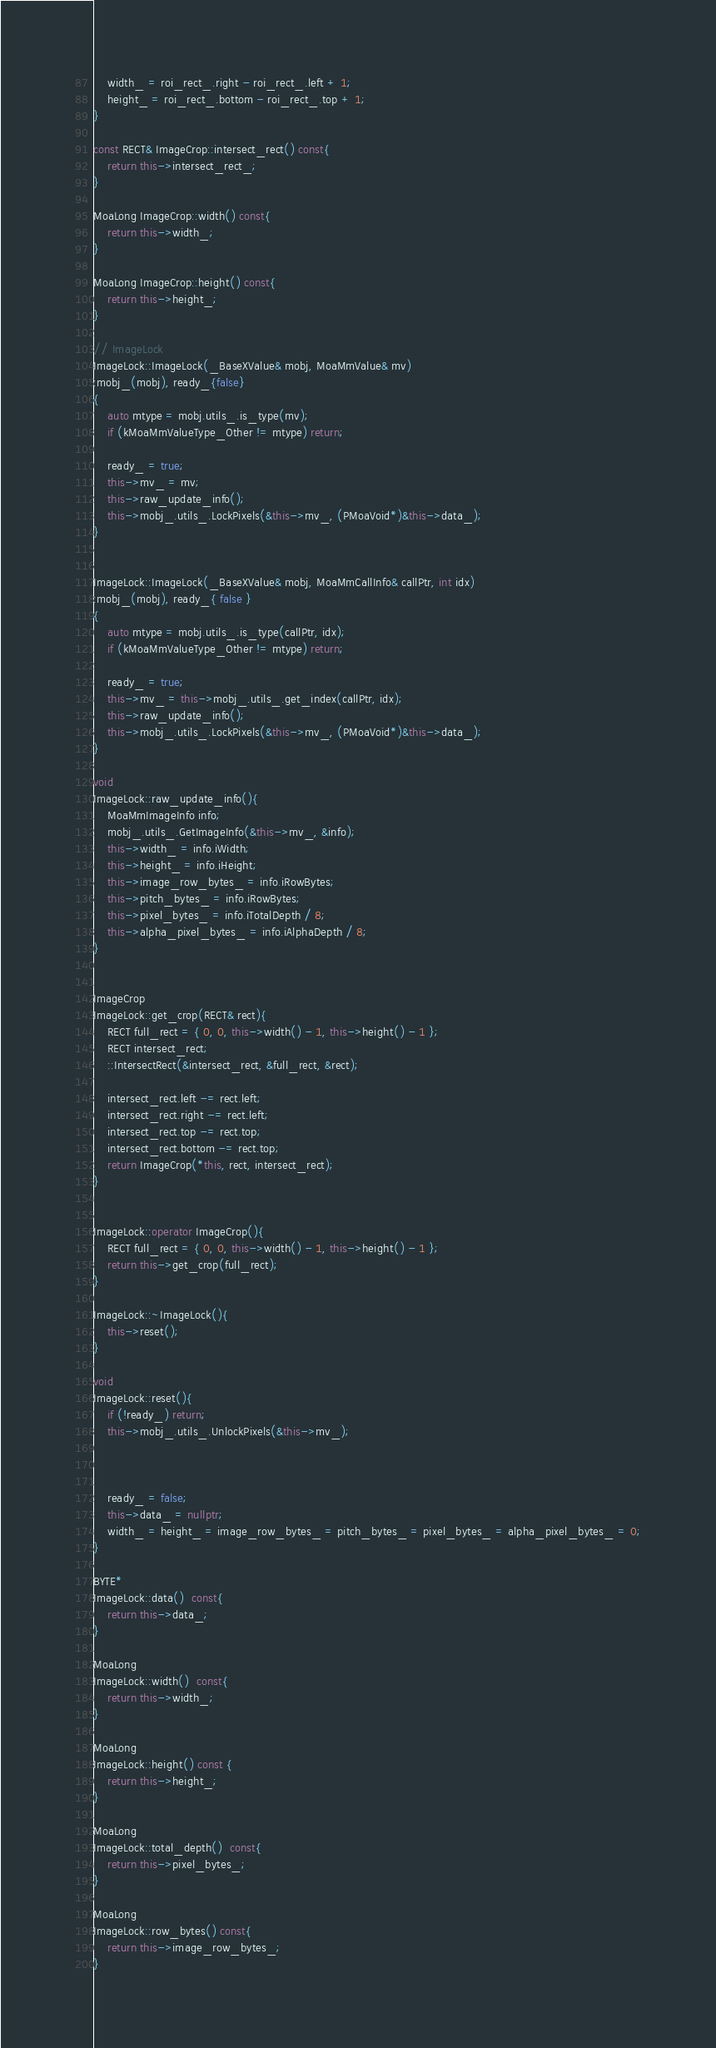<code> <loc_0><loc_0><loc_500><loc_500><_C++_>	width_ = roi_rect_.right - roi_rect_.left + 1;
	height_ = roi_rect_.bottom - roi_rect_.top + 1;
}

const RECT& ImageCrop::intersect_rect() const{
	return this->intersect_rect_;
}

MoaLong ImageCrop::width() const{
	return this->width_;
}

MoaLong ImageCrop::height() const{
	return this->height_;
}

// ImageLock
ImageLock::ImageLock(_BaseXValue& mobj, MoaMmValue& mv)
:mobj_(mobj), ready_{false}
{
	auto mtype = mobj.utils_.is_type(mv);
	if (kMoaMmValueType_Other != mtype) return;
		
	ready_ = true;
	this->mv_ = mv;
	this->raw_update_info();
	this->mobj_.utils_.LockPixels(&this->mv_, (PMoaVoid*)&this->data_);
}


ImageLock::ImageLock(_BaseXValue& mobj, MoaMmCallInfo& callPtr, int idx)
:mobj_(mobj), ready_{ false }
{
	auto mtype = mobj.utils_.is_type(callPtr, idx);
	if (kMoaMmValueType_Other != mtype) return;

	ready_ = true;
	this->mv_ = this->mobj_.utils_.get_index(callPtr, idx);
	this->raw_update_info();
	this->mobj_.utils_.LockPixels(&this->mv_, (PMoaVoid*)&this->data_);
}

void
ImageLock::raw_update_info(){
	MoaMmImageInfo info;
	mobj_.utils_.GetImageInfo(&this->mv_, &info);
	this->width_ = info.iWidth;
	this->height_ = info.iHeight;
	this->image_row_bytes_ = info.iRowBytes;
	this->pitch_bytes_ = info.iRowBytes;
	this->pixel_bytes_ = info.iTotalDepth / 8;
	this->alpha_pixel_bytes_ = info.iAlphaDepth / 8;
}


ImageCrop
ImageLock::get_crop(RECT& rect){
	RECT full_rect = { 0, 0, this->width() - 1, this->height() - 1 };
	RECT intersect_rect;
	::IntersectRect(&intersect_rect, &full_rect, &rect);

	intersect_rect.left -= rect.left;
	intersect_rect.right -= rect.left;
	intersect_rect.top -= rect.top;
	intersect_rect.bottom -= rect.top;
	return ImageCrop(*this, rect, intersect_rect);
}


ImageLock::operator ImageCrop(){
	RECT full_rect = { 0, 0, this->width() - 1, this->height() - 1 };
	return this->get_crop(full_rect);
}

ImageLock::~ImageLock(){
	this->reset();
}

void
ImageLock::reset(){
	if (!ready_) return;
	this->mobj_.utils_.UnlockPixels(&this->mv_);



	ready_ = false;
	this->data_ = nullptr;
	width_ = height_ = image_row_bytes_ = pitch_bytes_ = pixel_bytes_ = alpha_pixel_bytes_ = 0;
}

BYTE*
ImageLock::data()  const{
	return this->data_;
}

MoaLong
ImageLock::width()  const{
	return this->width_;
}

MoaLong
ImageLock::height() const {
	return this->height_;
}

MoaLong
ImageLock::total_depth()  const{
	return this->pixel_bytes_;
}

MoaLong
ImageLock::row_bytes() const{
	return this->image_row_bytes_;
}</code> 